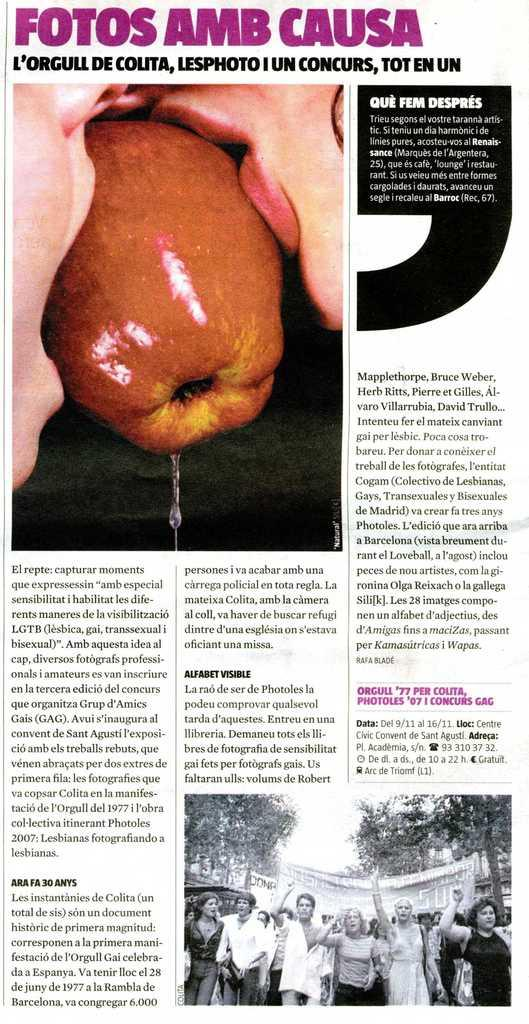<image>
Present a compact description of the photo's key features. a foreign newspaper page full of articles and pictures 